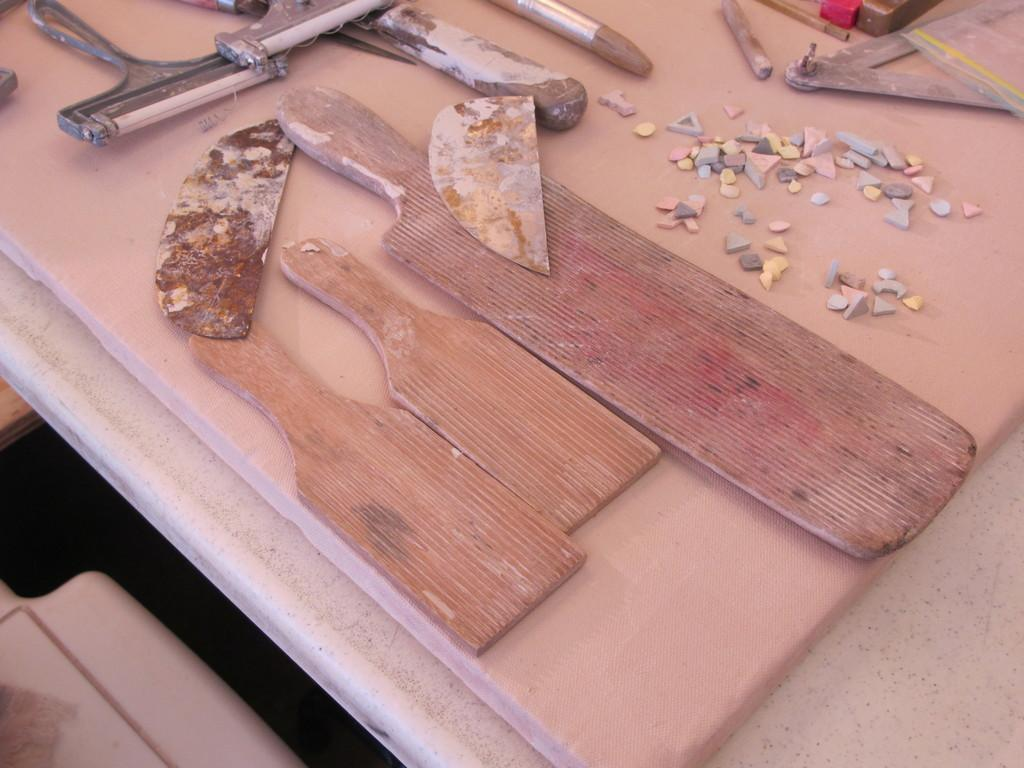What types of materials are used for the objects in the image? There are wooden, metal, and plastic objects in the image. Can you describe the objects on the right side of the image? There are tiny objects on the right side of the image. What type of magic is being performed with the vest and bottle in the image? There is no vest or bottle present in the image, and therefore no magic can be observed. 